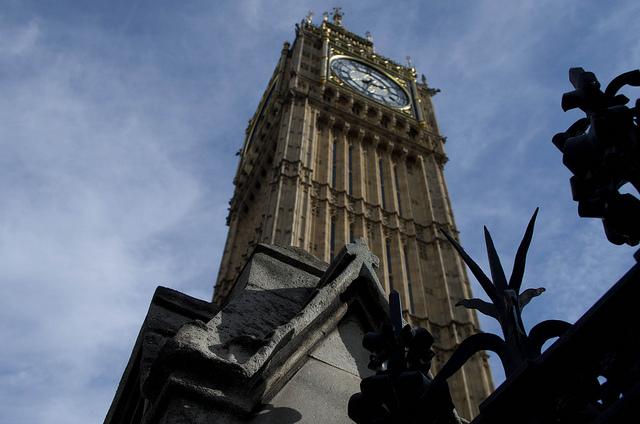Are there any plants?
Be succinct. No. Are there white clouds in the sky?
Short answer required. Yes. What shape is the rooftop below the clock?
Write a very short answer. Triangle. 